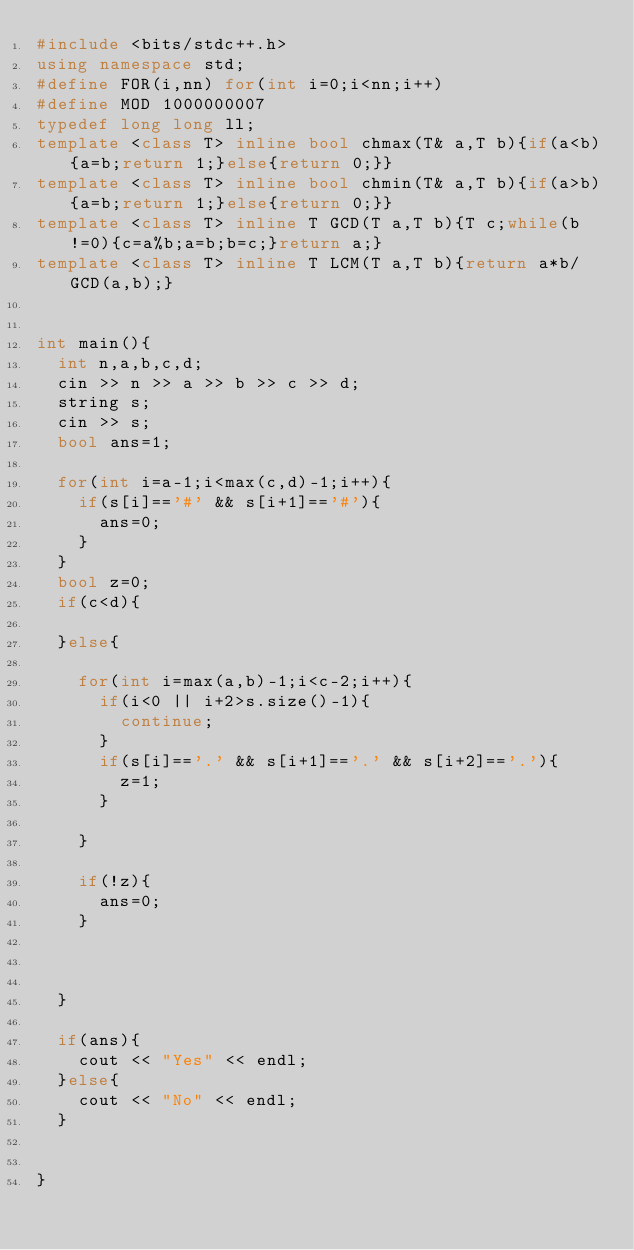Convert code to text. <code><loc_0><loc_0><loc_500><loc_500><_C++_>#include <bits/stdc++.h>
using namespace std;
#define FOR(i,nn) for(int i=0;i<nn;i++)
#define MOD 1000000007
typedef long long ll;
template <class T> inline bool chmax(T& a,T b){if(a<b){a=b;return 1;}else{return 0;}}
template <class T> inline bool chmin(T& a,T b){if(a>b){a=b;return 1;}else{return 0;}}
template <class T> inline T GCD(T a,T b){T c;while(b!=0){c=a%b;a=b;b=c;}return a;}
template <class T> inline T LCM(T a,T b){return a*b/GCD(a,b);}


int main(){
  int n,a,b,c,d;
  cin >> n >> a >> b >> c >> d;
  string s;
  cin >> s;
  bool ans=1;

  for(int i=a-1;i<max(c,d)-1;i++){
    if(s[i]=='#' && s[i+1]=='#'){
      ans=0;
    }
  }
  bool z=0;
  if(c<d){
    
  }else{

    for(int i=max(a,b)-1;i<c-2;i++){
      if(i<0 || i+2>s.size()-1){
        continue;
      }
      if(s[i]=='.' && s[i+1]=='.' && s[i+2]=='.'){
        z=1;
      }
      
    }

    if(!z){
      ans=0;
    }

    
        
  }

  if(ans){
    cout << "Yes" << endl;
  }else{
    cout << "No" << endl;
  }
  
  
}</code> 